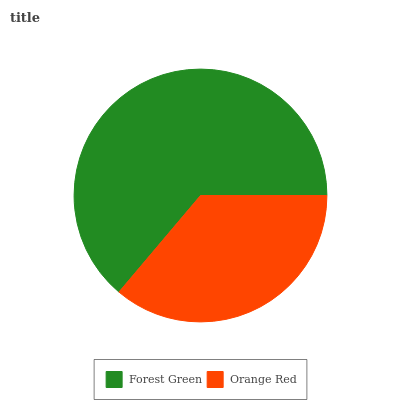Is Orange Red the minimum?
Answer yes or no. Yes. Is Forest Green the maximum?
Answer yes or no. Yes. Is Orange Red the maximum?
Answer yes or no. No. Is Forest Green greater than Orange Red?
Answer yes or no. Yes. Is Orange Red less than Forest Green?
Answer yes or no. Yes. Is Orange Red greater than Forest Green?
Answer yes or no. No. Is Forest Green less than Orange Red?
Answer yes or no. No. Is Forest Green the high median?
Answer yes or no. Yes. Is Orange Red the low median?
Answer yes or no. Yes. Is Orange Red the high median?
Answer yes or no. No. Is Forest Green the low median?
Answer yes or no. No. 